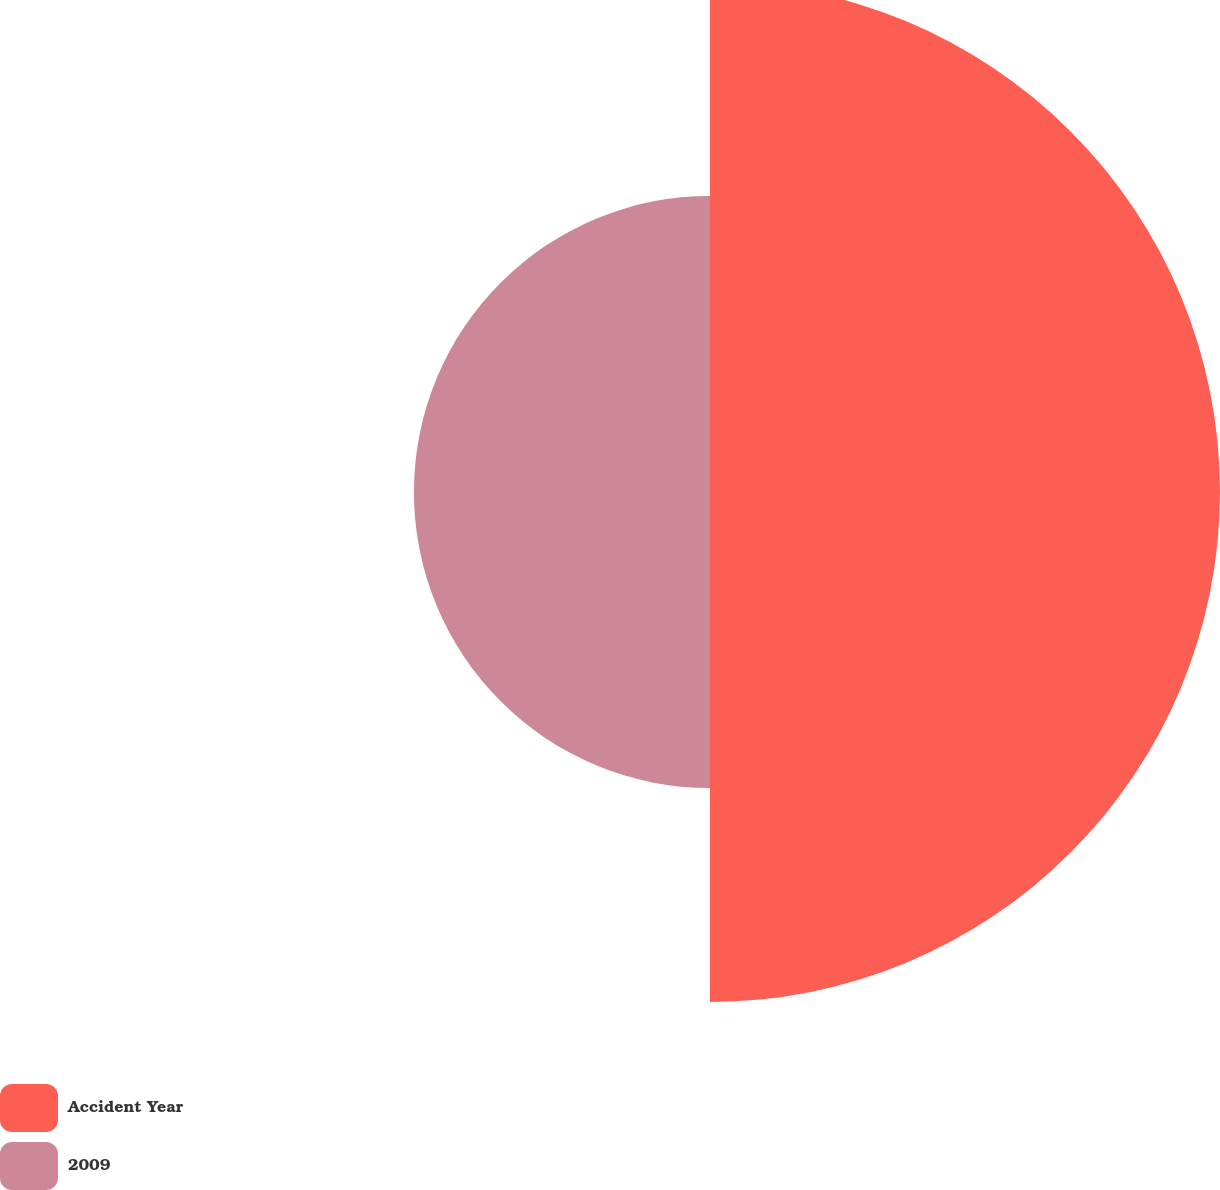Convert chart to OTSL. <chart><loc_0><loc_0><loc_500><loc_500><pie_chart><fcel>Accident Year<fcel>2009<nl><fcel>63.27%<fcel>36.73%<nl></chart> 